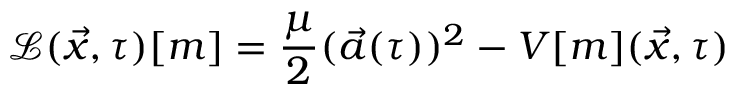<formula> <loc_0><loc_0><loc_500><loc_500>\mathcal { L } ( \vec { x } , \tau ) [ m ] = \frac { \mu } { 2 } ( \vec { a } ( \tau ) ) ^ { 2 } - V [ m ] ( \vec { x } , \tau )</formula> 